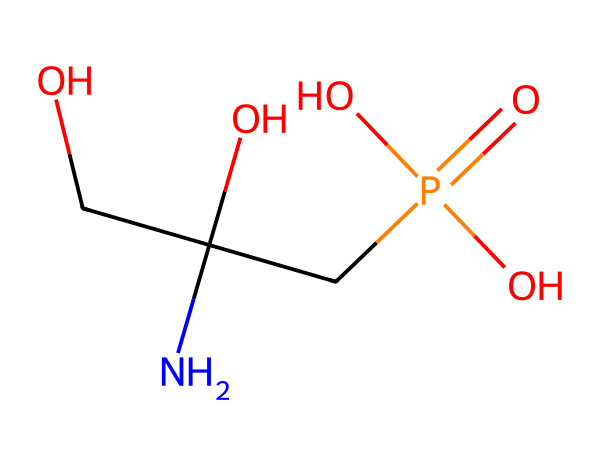How many carbon atoms are present in glyphosate? By analyzing the SMILES structure, we can see that the "C" represents carbon atoms. In the structure, there are three "C" characters indicating there are three carbon atoms.
Answer: three What is the functional group attached to the nitrogen in glyphosate? The nitrogen atom is connected to a hydroxyl group "O" and two carbon atoms, which suggests that the amine functional group is present. Additionally, "CP(=O)(O)O" indicates a phosphate functional group is closely associated. Therefore, the primary functional group is an amino group.
Answer: amino How many oxygen atoms are found in glyphosate? In the provided SMILES, each "O" represents an oxygen atom. Counting the occurrences reveals a total of four oxygen atoms in the structure.
Answer: four What type of herbicide class does glyphosate belong to? Glyphosate is a systemic herbicide that is classified as a non-selective herbicide. This means it can kill most plants by inhibiting a specific metabolic pathway present in plants.
Answer: non-selective Which element in glyphosate serves as a central atom in the phosphate group? The phosphorous "P" atom in the "CP(=O)(O)O" section indicates it is the central atom of the phosphate group, surrounded by oxygen atoms.
Answer: phosphorous What bond type is primarily responsible for the glyphosate's interaction with the target enzyme? Glyphosate primarily interacts with the target enzyme through hydrogen bonding due to the presence of hydroxyl (-OH) and amino (-NH) groups which can form hydrogen bonds with active sites on enzymes.
Answer: hydrogen bonding 